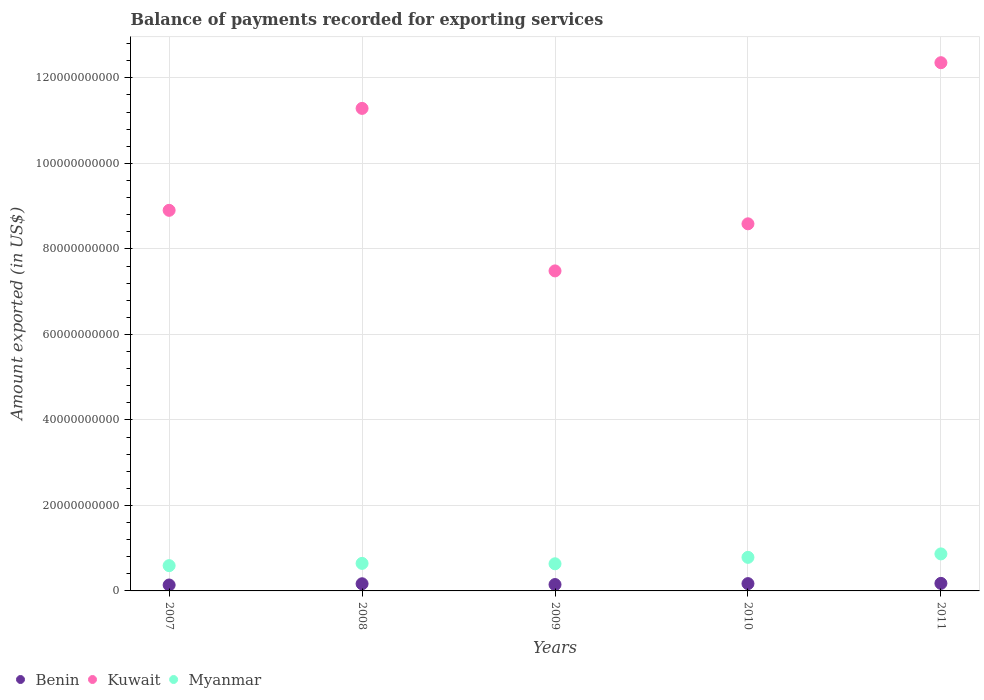What is the amount exported in Kuwait in 2007?
Make the answer very short. 8.90e+1. Across all years, what is the maximum amount exported in Kuwait?
Your answer should be compact. 1.24e+11. Across all years, what is the minimum amount exported in Myanmar?
Ensure brevity in your answer.  5.91e+09. What is the total amount exported in Myanmar in the graph?
Ensure brevity in your answer.  3.52e+1. What is the difference between the amount exported in Kuwait in 2010 and that in 2011?
Keep it short and to the point. -3.77e+1. What is the difference between the amount exported in Kuwait in 2011 and the amount exported in Myanmar in 2009?
Offer a very short reply. 1.17e+11. What is the average amount exported in Myanmar per year?
Offer a terse response. 7.04e+09. In the year 2008, what is the difference between the amount exported in Myanmar and amount exported in Benin?
Offer a terse response. 4.76e+09. In how many years, is the amount exported in Benin greater than 44000000000 US$?
Give a very brief answer. 0. What is the ratio of the amount exported in Myanmar in 2008 to that in 2011?
Ensure brevity in your answer.  0.74. Is the difference between the amount exported in Myanmar in 2008 and 2010 greater than the difference between the amount exported in Benin in 2008 and 2010?
Your answer should be compact. No. What is the difference between the highest and the second highest amount exported in Myanmar?
Your response must be concise. 8.06e+08. What is the difference between the highest and the lowest amount exported in Benin?
Your answer should be very brief. 3.80e+08. In how many years, is the amount exported in Kuwait greater than the average amount exported in Kuwait taken over all years?
Ensure brevity in your answer.  2. Is it the case that in every year, the sum of the amount exported in Benin and amount exported in Myanmar  is greater than the amount exported in Kuwait?
Give a very brief answer. No. Is the amount exported in Myanmar strictly less than the amount exported in Benin over the years?
Your response must be concise. No. How many dotlines are there?
Ensure brevity in your answer.  3. Are the values on the major ticks of Y-axis written in scientific E-notation?
Give a very brief answer. No. How many legend labels are there?
Keep it short and to the point. 3. What is the title of the graph?
Your response must be concise. Balance of payments recorded for exporting services. Does "Cayman Islands" appear as one of the legend labels in the graph?
Provide a short and direct response. No. What is the label or title of the Y-axis?
Ensure brevity in your answer.  Amount exported (in US$). What is the Amount exported (in US$) in Benin in 2007?
Give a very brief answer. 1.39e+09. What is the Amount exported (in US$) of Kuwait in 2007?
Provide a succinct answer. 8.90e+1. What is the Amount exported (in US$) in Myanmar in 2007?
Your answer should be compact. 5.91e+09. What is the Amount exported (in US$) in Benin in 2008?
Provide a succinct answer. 1.68e+09. What is the Amount exported (in US$) in Kuwait in 2008?
Your answer should be very brief. 1.13e+11. What is the Amount exported (in US$) in Myanmar in 2008?
Offer a very short reply. 6.44e+09. What is the Amount exported (in US$) of Benin in 2009?
Offer a terse response. 1.49e+09. What is the Amount exported (in US$) of Kuwait in 2009?
Give a very brief answer. 7.49e+1. What is the Amount exported (in US$) of Myanmar in 2009?
Your answer should be very brief. 6.35e+09. What is the Amount exported (in US$) in Benin in 2010?
Your answer should be compact. 1.71e+09. What is the Amount exported (in US$) in Kuwait in 2010?
Provide a succinct answer. 8.59e+1. What is the Amount exported (in US$) of Myanmar in 2010?
Your answer should be very brief. 7.85e+09. What is the Amount exported (in US$) of Benin in 2011?
Provide a succinct answer. 1.77e+09. What is the Amount exported (in US$) of Kuwait in 2011?
Ensure brevity in your answer.  1.24e+11. What is the Amount exported (in US$) of Myanmar in 2011?
Keep it short and to the point. 8.66e+09. Across all years, what is the maximum Amount exported (in US$) of Benin?
Your answer should be very brief. 1.77e+09. Across all years, what is the maximum Amount exported (in US$) of Kuwait?
Offer a very short reply. 1.24e+11. Across all years, what is the maximum Amount exported (in US$) of Myanmar?
Provide a short and direct response. 8.66e+09. Across all years, what is the minimum Amount exported (in US$) of Benin?
Provide a short and direct response. 1.39e+09. Across all years, what is the minimum Amount exported (in US$) in Kuwait?
Offer a terse response. 7.49e+1. Across all years, what is the minimum Amount exported (in US$) of Myanmar?
Provide a succinct answer. 5.91e+09. What is the total Amount exported (in US$) in Benin in the graph?
Your answer should be very brief. 8.02e+09. What is the total Amount exported (in US$) in Kuwait in the graph?
Your response must be concise. 4.86e+11. What is the total Amount exported (in US$) in Myanmar in the graph?
Offer a terse response. 3.52e+1. What is the difference between the Amount exported (in US$) in Benin in 2007 and that in 2008?
Your answer should be compact. -2.89e+08. What is the difference between the Amount exported (in US$) of Kuwait in 2007 and that in 2008?
Provide a succinct answer. -2.38e+1. What is the difference between the Amount exported (in US$) of Myanmar in 2007 and that in 2008?
Ensure brevity in your answer.  -5.28e+08. What is the difference between the Amount exported (in US$) of Benin in 2007 and that in 2009?
Keep it short and to the point. -1.03e+08. What is the difference between the Amount exported (in US$) in Kuwait in 2007 and that in 2009?
Offer a terse response. 1.42e+1. What is the difference between the Amount exported (in US$) in Myanmar in 2007 and that in 2009?
Offer a very short reply. -4.36e+08. What is the difference between the Amount exported (in US$) in Benin in 2007 and that in 2010?
Make the answer very short. -3.21e+08. What is the difference between the Amount exported (in US$) in Kuwait in 2007 and that in 2010?
Keep it short and to the point. 3.15e+09. What is the difference between the Amount exported (in US$) in Myanmar in 2007 and that in 2010?
Ensure brevity in your answer.  -1.94e+09. What is the difference between the Amount exported (in US$) of Benin in 2007 and that in 2011?
Make the answer very short. -3.80e+08. What is the difference between the Amount exported (in US$) of Kuwait in 2007 and that in 2011?
Offer a terse response. -3.45e+1. What is the difference between the Amount exported (in US$) in Myanmar in 2007 and that in 2011?
Provide a succinct answer. -2.75e+09. What is the difference between the Amount exported (in US$) in Benin in 2008 and that in 2009?
Your response must be concise. 1.87e+08. What is the difference between the Amount exported (in US$) of Kuwait in 2008 and that in 2009?
Provide a short and direct response. 3.80e+1. What is the difference between the Amount exported (in US$) of Myanmar in 2008 and that in 2009?
Provide a short and direct response. 9.17e+07. What is the difference between the Amount exported (in US$) in Benin in 2008 and that in 2010?
Offer a terse response. -3.23e+07. What is the difference between the Amount exported (in US$) in Kuwait in 2008 and that in 2010?
Offer a very short reply. 2.70e+1. What is the difference between the Amount exported (in US$) of Myanmar in 2008 and that in 2010?
Ensure brevity in your answer.  -1.41e+09. What is the difference between the Amount exported (in US$) in Benin in 2008 and that in 2011?
Keep it short and to the point. -9.04e+07. What is the difference between the Amount exported (in US$) in Kuwait in 2008 and that in 2011?
Your response must be concise. -1.07e+1. What is the difference between the Amount exported (in US$) of Myanmar in 2008 and that in 2011?
Provide a short and direct response. -2.22e+09. What is the difference between the Amount exported (in US$) of Benin in 2009 and that in 2010?
Offer a very short reply. -2.19e+08. What is the difference between the Amount exported (in US$) in Kuwait in 2009 and that in 2010?
Your answer should be very brief. -1.10e+1. What is the difference between the Amount exported (in US$) of Myanmar in 2009 and that in 2010?
Ensure brevity in your answer.  -1.50e+09. What is the difference between the Amount exported (in US$) of Benin in 2009 and that in 2011?
Offer a terse response. -2.77e+08. What is the difference between the Amount exported (in US$) of Kuwait in 2009 and that in 2011?
Ensure brevity in your answer.  -4.87e+1. What is the difference between the Amount exported (in US$) of Myanmar in 2009 and that in 2011?
Make the answer very short. -2.31e+09. What is the difference between the Amount exported (in US$) in Benin in 2010 and that in 2011?
Provide a succinct answer. -5.81e+07. What is the difference between the Amount exported (in US$) of Kuwait in 2010 and that in 2011?
Your response must be concise. -3.77e+1. What is the difference between the Amount exported (in US$) in Myanmar in 2010 and that in 2011?
Provide a succinct answer. -8.06e+08. What is the difference between the Amount exported (in US$) of Benin in 2007 and the Amount exported (in US$) of Kuwait in 2008?
Provide a succinct answer. -1.11e+11. What is the difference between the Amount exported (in US$) in Benin in 2007 and the Amount exported (in US$) in Myanmar in 2008?
Your answer should be very brief. -5.05e+09. What is the difference between the Amount exported (in US$) in Kuwait in 2007 and the Amount exported (in US$) in Myanmar in 2008?
Give a very brief answer. 8.26e+1. What is the difference between the Amount exported (in US$) of Benin in 2007 and the Amount exported (in US$) of Kuwait in 2009?
Make the answer very short. -7.35e+1. What is the difference between the Amount exported (in US$) in Benin in 2007 and the Amount exported (in US$) in Myanmar in 2009?
Make the answer very short. -4.96e+09. What is the difference between the Amount exported (in US$) of Kuwait in 2007 and the Amount exported (in US$) of Myanmar in 2009?
Your answer should be compact. 8.27e+1. What is the difference between the Amount exported (in US$) in Benin in 2007 and the Amount exported (in US$) in Kuwait in 2010?
Provide a succinct answer. -8.45e+1. What is the difference between the Amount exported (in US$) in Benin in 2007 and the Amount exported (in US$) in Myanmar in 2010?
Provide a succinct answer. -6.47e+09. What is the difference between the Amount exported (in US$) in Kuwait in 2007 and the Amount exported (in US$) in Myanmar in 2010?
Your response must be concise. 8.12e+1. What is the difference between the Amount exported (in US$) of Benin in 2007 and the Amount exported (in US$) of Kuwait in 2011?
Your response must be concise. -1.22e+11. What is the difference between the Amount exported (in US$) of Benin in 2007 and the Amount exported (in US$) of Myanmar in 2011?
Your answer should be compact. -7.27e+09. What is the difference between the Amount exported (in US$) of Kuwait in 2007 and the Amount exported (in US$) of Myanmar in 2011?
Provide a short and direct response. 8.04e+1. What is the difference between the Amount exported (in US$) in Benin in 2008 and the Amount exported (in US$) in Kuwait in 2009?
Your response must be concise. -7.32e+1. What is the difference between the Amount exported (in US$) of Benin in 2008 and the Amount exported (in US$) of Myanmar in 2009?
Offer a very short reply. -4.67e+09. What is the difference between the Amount exported (in US$) in Kuwait in 2008 and the Amount exported (in US$) in Myanmar in 2009?
Provide a succinct answer. 1.07e+11. What is the difference between the Amount exported (in US$) in Benin in 2008 and the Amount exported (in US$) in Kuwait in 2010?
Offer a terse response. -8.42e+1. What is the difference between the Amount exported (in US$) of Benin in 2008 and the Amount exported (in US$) of Myanmar in 2010?
Your response must be concise. -6.18e+09. What is the difference between the Amount exported (in US$) in Kuwait in 2008 and the Amount exported (in US$) in Myanmar in 2010?
Offer a terse response. 1.05e+11. What is the difference between the Amount exported (in US$) of Benin in 2008 and the Amount exported (in US$) of Kuwait in 2011?
Offer a terse response. -1.22e+11. What is the difference between the Amount exported (in US$) in Benin in 2008 and the Amount exported (in US$) in Myanmar in 2011?
Provide a succinct answer. -6.98e+09. What is the difference between the Amount exported (in US$) in Kuwait in 2008 and the Amount exported (in US$) in Myanmar in 2011?
Your response must be concise. 1.04e+11. What is the difference between the Amount exported (in US$) in Benin in 2009 and the Amount exported (in US$) in Kuwait in 2010?
Your answer should be very brief. -8.44e+1. What is the difference between the Amount exported (in US$) of Benin in 2009 and the Amount exported (in US$) of Myanmar in 2010?
Your response must be concise. -6.36e+09. What is the difference between the Amount exported (in US$) of Kuwait in 2009 and the Amount exported (in US$) of Myanmar in 2010?
Keep it short and to the point. 6.70e+1. What is the difference between the Amount exported (in US$) in Benin in 2009 and the Amount exported (in US$) in Kuwait in 2011?
Offer a very short reply. -1.22e+11. What is the difference between the Amount exported (in US$) in Benin in 2009 and the Amount exported (in US$) in Myanmar in 2011?
Provide a succinct answer. -7.17e+09. What is the difference between the Amount exported (in US$) in Kuwait in 2009 and the Amount exported (in US$) in Myanmar in 2011?
Offer a terse response. 6.62e+1. What is the difference between the Amount exported (in US$) in Benin in 2010 and the Amount exported (in US$) in Kuwait in 2011?
Make the answer very short. -1.22e+11. What is the difference between the Amount exported (in US$) in Benin in 2010 and the Amount exported (in US$) in Myanmar in 2011?
Give a very brief answer. -6.95e+09. What is the difference between the Amount exported (in US$) in Kuwait in 2010 and the Amount exported (in US$) in Myanmar in 2011?
Offer a very short reply. 7.72e+1. What is the average Amount exported (in US$) of Benin per year?
Keep it short and to the point. 1.60e+09. What is the average Amount exported (in US$) of Kuwait per year?
Your answer should be compact. 9.72e+1. What is the average Amount exported (in US$) in Myanmar per year?
Offer a terse response. 7.04e+09. In the year 2007, what is the difference between the Amount exported (in US$) of Benin and Amount exported (in US$) of Kuwait?
Give a very brief answer. -8.76e+1. In the year 2007, what is the difference between the Amount exported (in US$) of Benin and Amount exported (in US$) of Myanmar?
Provide a short and direct response. -4.53e+09. In the year 2007, what is the difference between the Amount exported (in US$) in Kuwait and Amount exported (in US$) in Myanmar?
Your response must be concise. 8.31e+1. In the year 2008, what is the difference between the Amount exported (in US$) of Benin and Amount exported (in US$) of Kuwait?
Provide a succinct answer. -1.11e+11. In the year 2008, what is the difference between the Amount exported (in US$) in Benin and Amount exported (in US$) in Myanmar?
Offer a terse response. -4.76e+09. In the year 2008, what is the difference between the Amount exported (in US$) of Kuwait and Amount exported (in US$) of Myanmar?
Provide a succinct answer. 1.06e+11. In the year 2009, what is the difference between the Amount exported (in US$) of Benin and Amount exported (in US$) of Kuwait?
Ensure brevity in your answer.  -7.34e+1. In the year 2009, what is the difference between the Amount exported (in US$) of Benin and Amount exported (in US$) of Myanmar?
Offer a very short reply. -4.86e+09. In the year 2009, what is the difference between the Amount exported (in US$) of Kuwait and Amount exported (in US$) of Myanmar?
Your answer should be compact. 6.85e+1. In the year 2010, what is the difference between the Amount exported (in US$) in Benin and Amount exported (in US$) in Kuwait?
Your answer should be compact. -8.42e+1. In the year 2010, what is the difference between the Amount exported (in US$) in Benin and Amount exported (in US$) in Myanmar?
Give a very brief answer. -6.14e+09. In the year 2010, what is the difference between the Amount exported (in US$) of Kuwait and Amount exported (in US$) of Myanmar?
Make the answer very short. 7.80e+1. In the year 2011, what is the difference between the Amount exported (in US$) in Benin and Amount exported (in US$) in Kuwait?
Give a very brief answer. -1.22e+11. In the year 2011, what is the difference between the Amount exported (in US$) of Benin and Amount exported (in US$) of Myanmar?
Your answer should be very brief. -6.89e+09. In the year 2011, what is the difference between the Amount exported (in US$) in Kuwait and Amount exported (in US$) in Myanmar?
Give a very brief answer. 1.15e+11. What is the ratio of the Amount exported (in US$) of Benin in 2007 to that in 2008?
Offer a terse response. 0.83. What is the ratio of the Amount exported (in US$) in Kuwait in 2007 to that in 2008?
Your answer should be very brief. 0.79. What is the ratio of the Amount exported (in US$) of Myanmar in 2007 to that in 2008?
Offer a very short reply. 0.92. What is the ratio of the Amount exported (in US$) of Benin in 2007 to that in 2009?
Provide a short and direct response. 0.93. What is the ratio of the Amount exported (in US$) in Kuwait in 2007 to that in 2009?
Provide a short and direct response. 1.19. What is the ratio of the Amount exported (in US$) of Myanmar in 2007 to that in 2009?
Give a very brief answer. 0.93. What is the ratio of the Amount exported (in US$) in Benin in 2007 to that in 2010?
Provide a short and direct response. 0.81. What is the ratio of the Amount exported (in US$) of Kuwait in 2007 to that in 2010?
Your answer should be compact. 1.04. What is the ratio of the Amount exported (in US$) in Myanmar in 2007 to that in 2010?
Your response must be concise. 0.75. What is the ratio of the Amount exported (in US$) in Benin in 2007 to that in 2011?
Make the answer very short. 0.79. What is the ratio of the Amount exported (in US$) of Kuwait in 2007 to that in 2011?
Keep it short and to the point. 0.72. What is the ratio of the Amount exported (in US$) of Myanmar in 2007 to that in 2011?
Offer a very short reply. 0.68. What is the ratio of the Amount exported (in US$) in Benin in 2008 to that in 2009?
Ensure brevity in your answer.  1.13. What is the ratio of the Amount exported (in US$) of Kuwait in 2008 to that in 2009?
Provide a succinct answer. 1.51. What is the ratio of the Amount exported (in US$) of Myanmar in 2008 to that in 2009?
Provide a short and direct response. 1.01. What is the ratio of the Amount exported (in US$) in Benin in 2008 to that in 2010?
Keep it short and to the point. 0.98. What is the ratio of the Amount exported (in US$) of Kuwait in 2008 to that in 2010?
Give a very brief answer. 1.31. What is the ratio of the Amount exported (in US$) in Myanmar in 2008 to that in 2010?
Ensure brevity in your answer.  0.82. What is the ratio of the Amount exported (in US$) in Benin in 2008 to that in 2011?
Your answer should be compact. 0.95. What is the ratio of the Amount exported (in US$) of Kuwait in 2008 to that in 2011?
Your answer should be compact. 0.91. What is the ratio of the Amount exported (in US$) of Myanmar in 2008 to that in 2011?
Offer a very short reply. 0.74. What is the ratio of the Amount exported (in US$) of Benin in 2009 to that in 2010?
Offer a terse response. 0.87. What is the ratio of the Amount exported (in US$) in Kuwait in 2009 to that in 2010?
Provide a short and direct response. 0.87. What is the ratio of the Amount exported (in US$) of Myanmar in 2009 to that in 2010?
Keep it short and to the point. 0.81. What is the ratio of the Amount exported (in US$) in Benin in 2009 to that in 2011?
Keep it short and to the point. 0.84. What is the ratio of the Amount exported (in US$) in Kuwait in 2009 to that in 2011?
Your response must be concise. 0.61. What is the ratio of the Amount exported (in US$) in Myanmar in 2009 to that in 2011?
Make the answer very short. 0.73. What is the ratio of the Amount exported (in US$) of Benin in 2010 to that in 2011?
Ensure brevity in your answer.  0.97. What is the ratio of the Amount exported (in US$) in Kuwait in 2010 to that in 2011?
Provide a succinct answer. 0.69. What is the ratio of the Amount exported (in US$) in Myanmar in 2010 to that in 2011?
Ensure brevity in your answer.  0.91. What is the difference between the highest and the second highest Amount exported (in US$) of Benin?
Keep it short and to the point. 5.81e+07. What is the difference between the highest and the second highest Amount exported (in US$) of Kuwait?
Keep it short and to the point. 1.07e+1. What is the difference between the highest and the second highest Amount exported (in US$) in Myanmar?
Make the answer very short. 8.06e+08. What is the difference between the highest and the lowest Amount exported (in US$) in Benin?
Your response must be concise. 3.80e+08. What is the difference between the highest and the lowest Amount exported (in US$) in Kuwait?
Offer a terse response. 4.87e+1. What is the difference between the highest and the lowest Amount exported (in US$) of Myanmar?
Make the answer very short. 2.75e+09. 